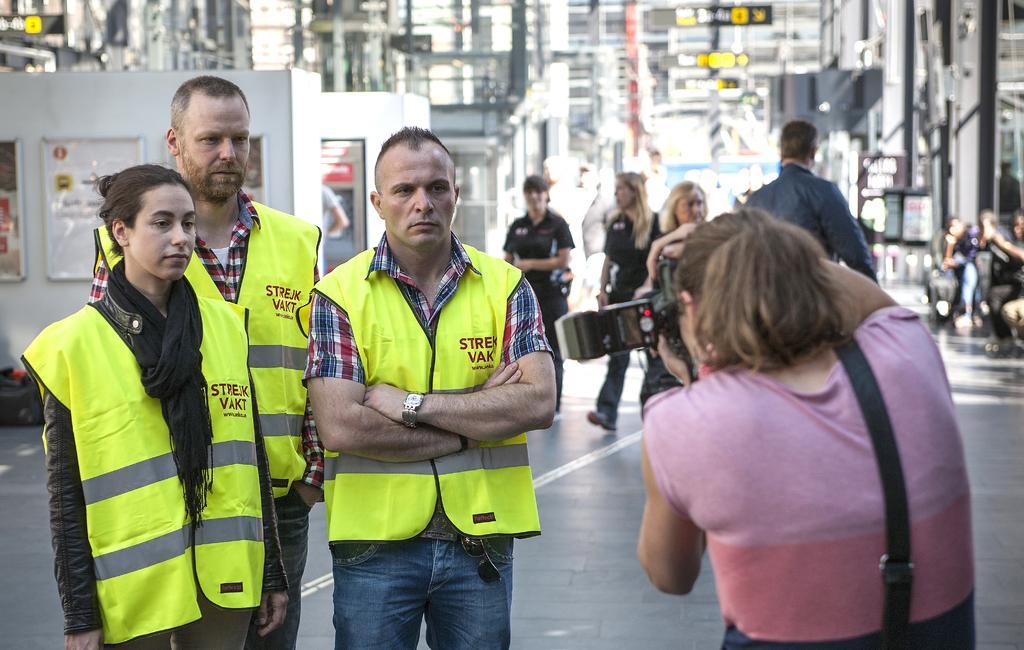In one or two sentences, can you explain what this image depicts? In the foreground of the image there are three people standing. To the right side of the image there is a lady holding a camera. In the background of the image there are people walking. There are machines. There are rods. At the bottom of the image there is floor. 